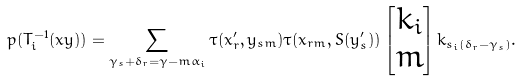<formula> <loc_0><loc_0><loc_500><loc_500>p ( T _ { i } ^ { - 1 } ( x y ) ) = \sum _ { \gamma _ { s } + \delta _ { r } = \gamma - m \alpha _ { i } } \tau ( x ^ { \prime } _ { r } , y _ { s m } ) \tau ( x _ { r m } , S ( y ^ { \prime } _ { s } ) ) \begin{bmatrix} k _ { i } \\ m \end{bmatrix} k _ { s _ { i } ( \delta _ { r } - \gamma _ { s } ) } .</formula> 